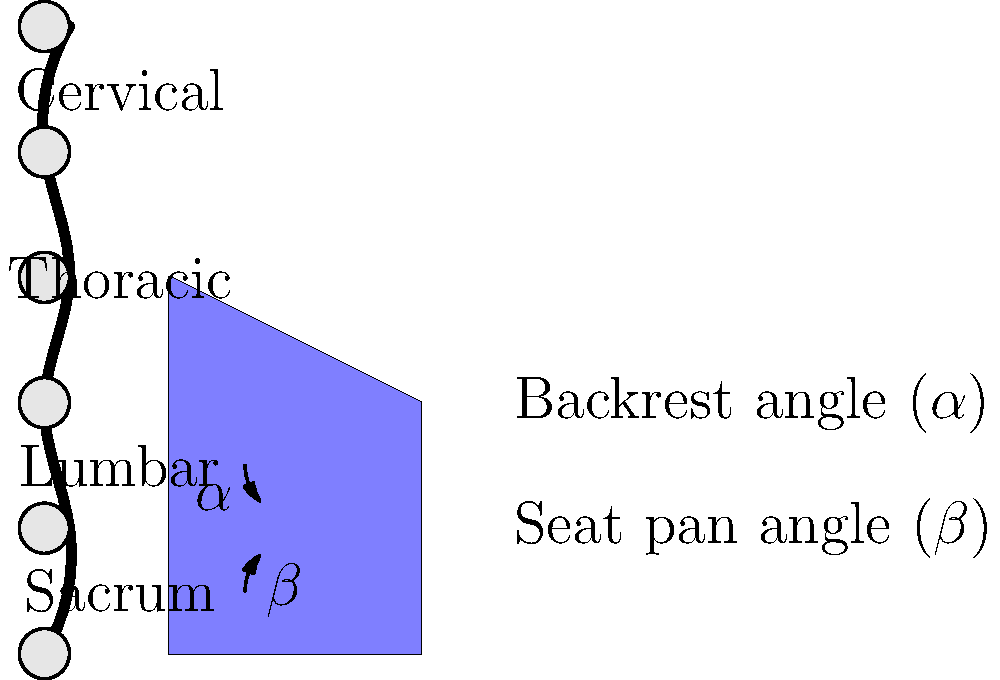As a career counselor in the automotive industry, you're advising a car manufacturer on ergonomic seat design. Using the provided spine diagram and seat illustration, what is the recommended range for the backrest angle ($\alpha$) to support the natural curvature of the spine and reduce lower back strain during long drives? To determine the recommended range for the backrest angle ($\alpha$), we need to consider the natural curvature of the spine and ergonomic principles:

1. The human spine has three natural curves:
   - Cervical (neck) curve
   - Thoracic (upper back) curve
   - Lumbar (lower back) curve

2. The lumbar curve is particularly important for seat design, as it needs proper support to maintain its natural lordosis (inward curve).

3. Research in automotive ergonomics suggests that:
   - A completely upright backrest (90°) doesn't provide adequate support for the spine's natural curves.
   - A backrest that's too reclined can cause the pelvis to tilt backward, flattening the lumbar curve.

4. The optimal backrest angle range should:
   - Support the natural lumbar lordosis
   - Distribute body weight evenly
   - Reduce pressure on the intervertebral discs

5. Studies have shown that a backrest angle between 100° and 110° from vertical provides the best compromise between spinal support and comfort for most adults during prolonged sitting.

6. This range (100°-110°) corresponds to a backrest angle ($\alpha$) of 10°-20° from vertical in our diagram.

7. It's important to note that some adjustability should be provided to accommodate individual preferences and body types.

Therefore, the recommended range for the backrest angle ($\alpha$) is 10°-20° from vertical, or 100°-110° when measured from a horizontal plane.
Answer: 10°-20° from vertical (100°-110° from horizontal) 